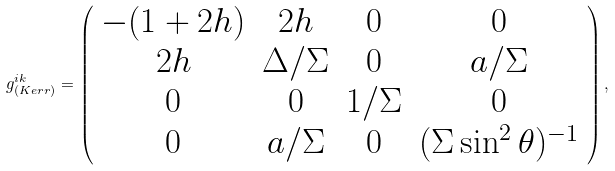<formula> <loc_0><loc_0><loc_500><loc_500>g _ { ( K e r r ) } ^ { i k } = \left ( \begin{array} { c c c c } - ( 1 + 2 h ) & 2 h & 0 & 0 \\ 2 h & \Delta / \Sigma & 0 & a / \Sigma \\ 0 & 0 & 1 / { \Sigma } & 0 \\ 0 & a / { \Sigma } & 0 & ( \Sigma \sin ^ { 2 } \theta ) ^ { - 1 } \end{array} \right ) ,</formula> 